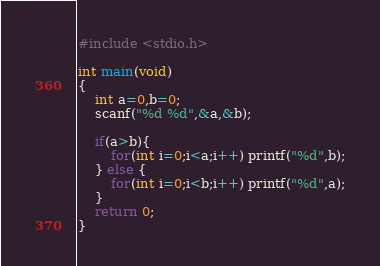Convert code to text. <code><loc_0><loc_0><loc_500><loc_500><_C_>#include <stdio.h>

int main(void)
{
    int a=0,b=0;
    scanf("%d %d",&a,&b);
    
    if(a>b){
        for(int i=0;i<a;i++) printf("%d",b);
    } else {
        for(int i=0;i<b;i++) printf("%d",a);
    }
    return 0;
}
</code> 